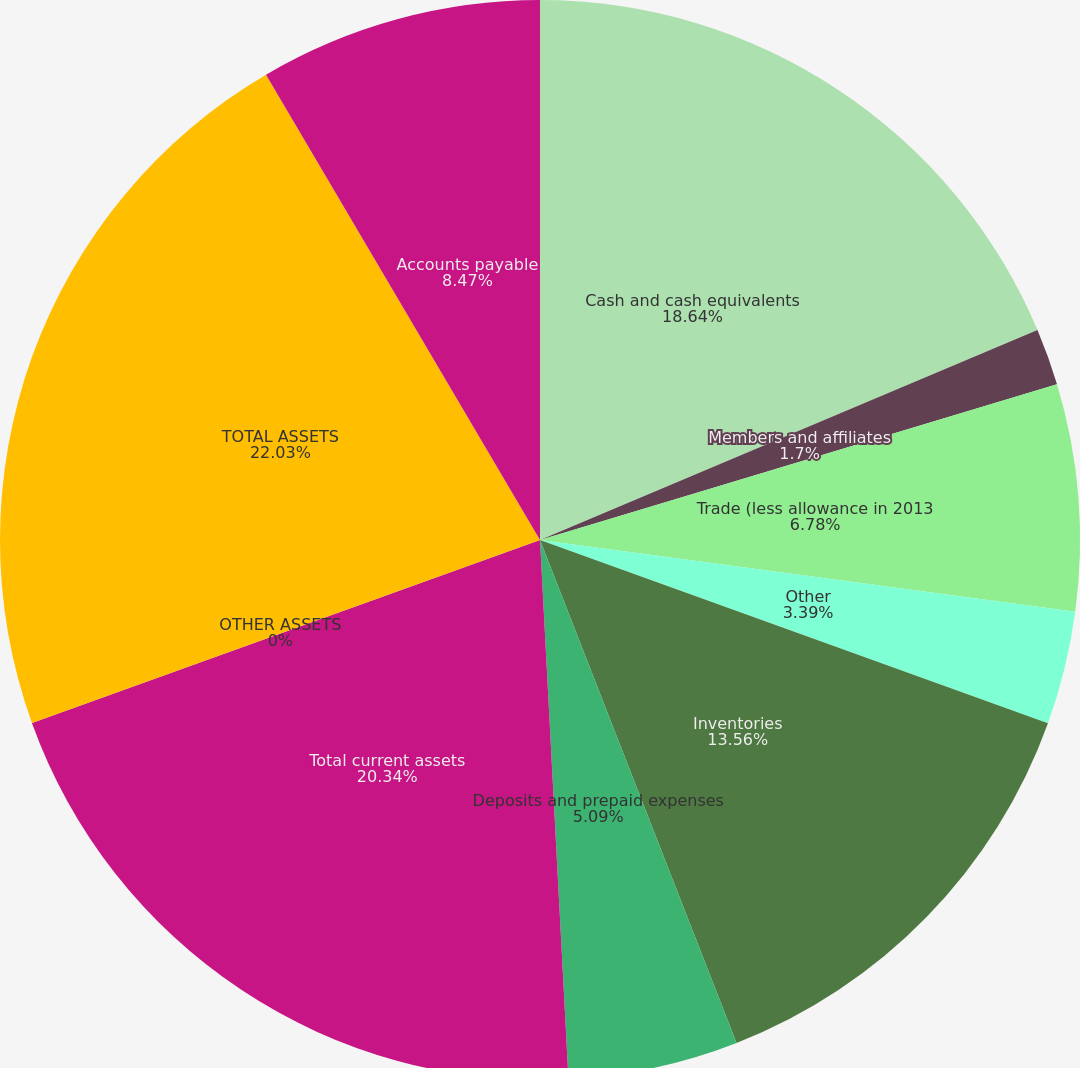Convert chart to OTSL. <chart><loc_0><loc_0><loc_500><loc_500><pie_chart><fcel>Cash and cash equivalents<fcel>Members and affiliates<fcel>Trade (less allowance in 2013<fcel>Other<fcel>Inventories<fcel>Deposits and prepaid expenses<fcel>Total current assets<fcel>OTHER ASSETS<fcel>TOTAL ASSETS<fcel>Accounts payable<nl><fcel>18.64%<fcel>1.7%<fcel>6.78%<fcel>3.39%<fcel>13.56%<fcel>5.09%<fcel>20.34%<fcel>0.0%<fcel>22.03%<fcel>8.47%<nl></chart> 